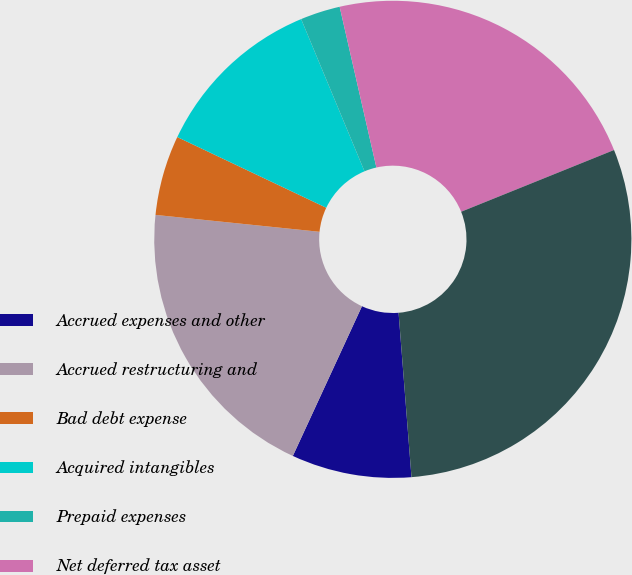<chart> <loc_0><loc_0><loc_500><loc_500><pie_chart><fcel>Accrued expenses and other<fcel>Accrued restructuring and<fcel>Bad debt expense<fcel>Acquired intangibles<fcel>Prepaid expenses<fcel>Net deferred tax asset<fcel>Less Current net deferred tax<nl><fcel>8.13%<fcel>19.75%<fcel>5.42%<fcel>11.67%<fcel>2.7%<fcel>22.47%<fcel>29.86%<nl></chart> 